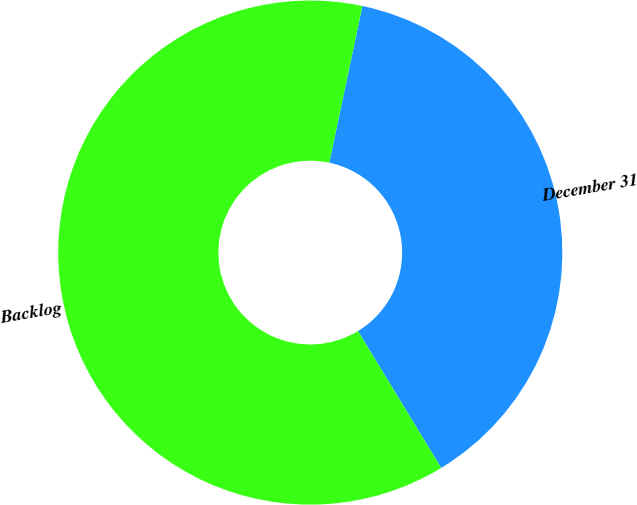<chart> <loc_0><loc_0><loc_500><loc_500><pie_chart><fcel>December 31<fcel>Backlog<nl><fcel>37.99%<fcel>62.01%<nl></chart> 